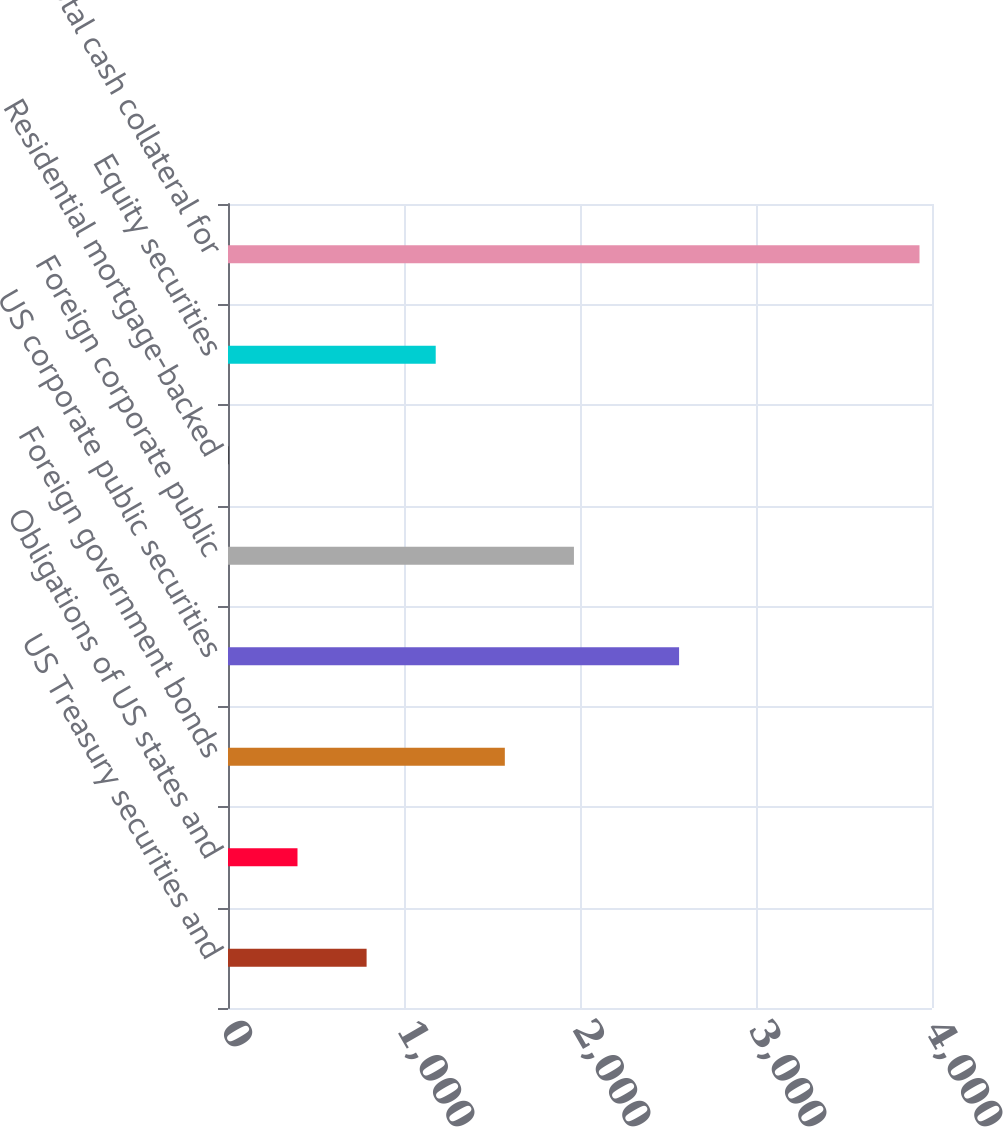<chart> <loc_0><loc_0><loc_500><loc_500><bar_chart><fcel>US Treasury securities and<fcel>Obligations of US states and<fcel>Foreign government bonds<fcel>US corporate public securities<fcel>Foreign corporate public<fcel>Residential mortgage-backed<fcel>Equity securities<fcel>Total cash collateral for<nl><fcel>787.53<fcel>394.85<fcel>1572.89<fcel>2563<fcel>1965.57<fcel>2.17<fcel>1180.21<fcel>3929<nl></chart> 